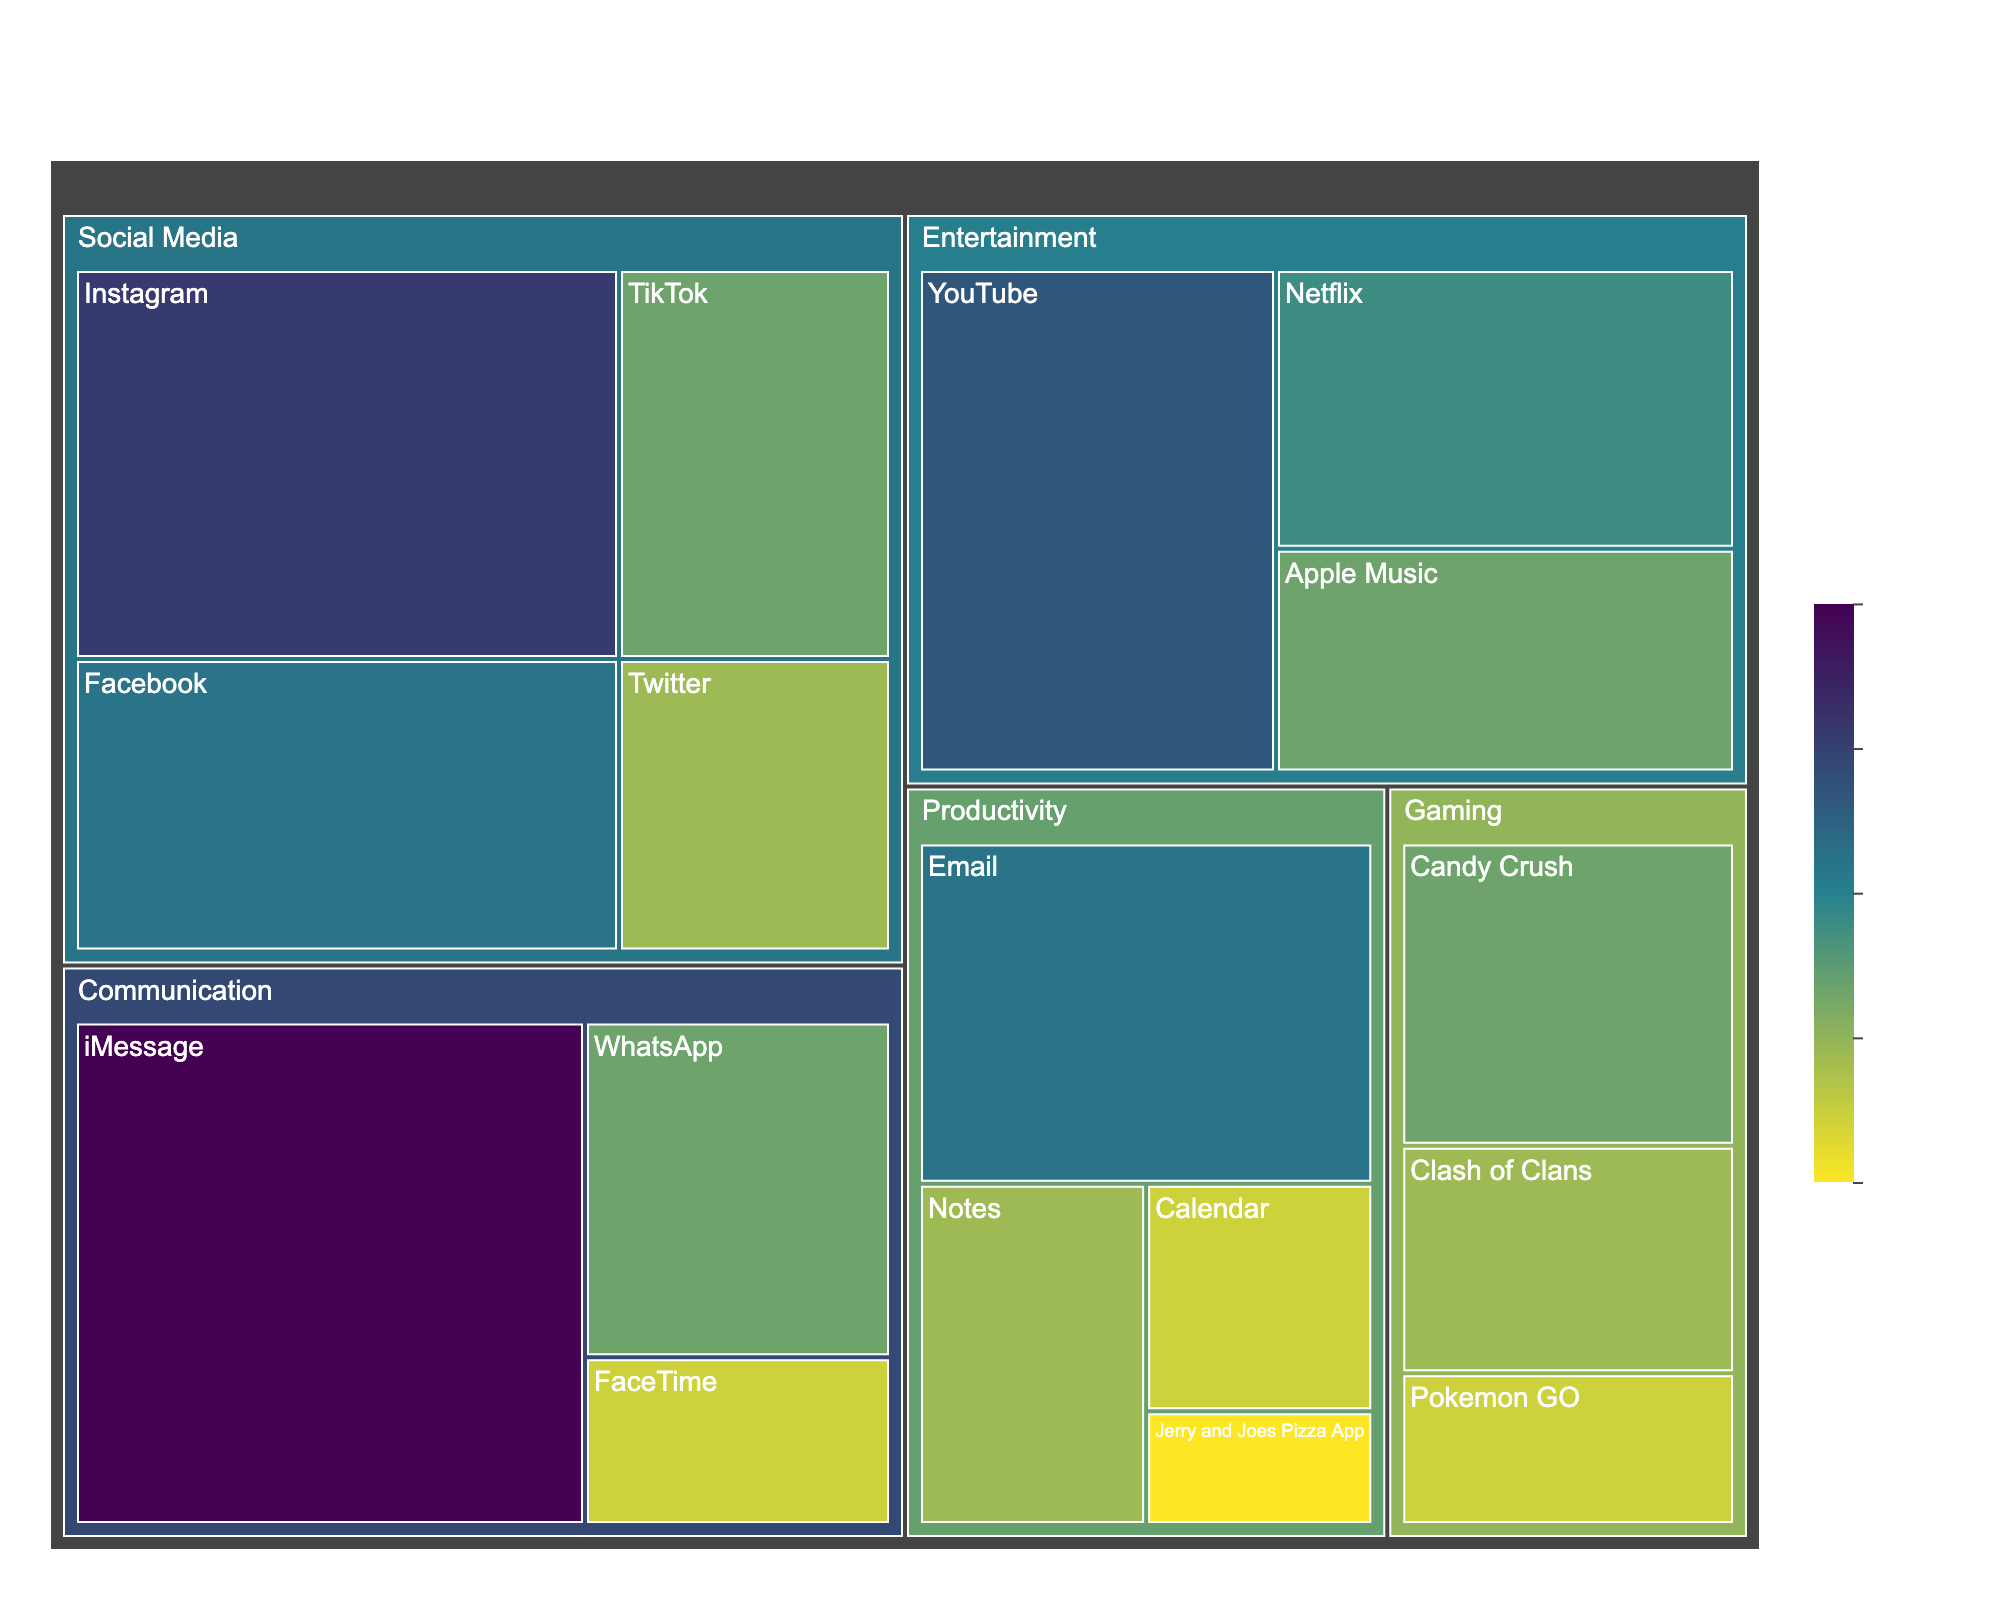What is the title of the treemap? The title of the treemap is usually located at the top of the figure. In this case, the title is "Smartphone Usage Statistics" with a subtitle "Time Spent on Various Activities".
Answer: Smartphone Usage Statistics Which activity category has the highest time spent? To find the category with the highest time spent, look for the largest section in the treemap. The largest section corresponds to "Communication" as it includes the highest time spent subactivity, iMessage.
Answer: Communication How much time is spent on Instagram compared to Facebook? Identify the time spent on Instagram and Facebook from the treemap. Instagram has 120 minutes, and Facebook has 90 minutes. Subtract to find the difference. 120 - 90 = 30 minutes.
Answer: 30 minutes Combine the time spent on all productivity activities. Sum the time spent on Email (90), Calendar (30), Notes (45), and Jerry and Joes Pizza App (15). The total is 90 + 30 + 45 + 15 = 180 minutes.
Answer: 180 minutes Which subcategory under Entertainment has the least time spent? Look under the Entertainment section and compare the subcategories: YouTube (105 minutes), Netflix (75 minutes), Apple Music (60 minutes). Apple Music has the least time spent.
Answer: Apple Music Which has more time spent: all Gaming activities combined or all Social Media activities combined? Sum the time for each category. Gaming: Candy Crush (60) + Clash of Clans (45) + Pokemon GO (30) = 135 minutes. Social Media: Instagram (120) + Facebook (90) + TikTok (60) + Twitter (45) = 315 minutes. Compare the sums.
Answer: Social Media What is the average time spent per subactivity in Communication? Sum the time spent on each subactivity in Communication: iMessage (150), WhatsApp (60), FaceTime (30) = 240 minutes. There are 3 subactivities, so average is 240/3 = 80 minutes.
Answer: 80 minutes How does the time spent on YouTube compare to time spent on Email? Look at the figures for each: YouTube is 105 minutes and Email is 90 minutes. Compare them; YouTube has more time spent.
Answer: YouTube What percentage of the total time is spent on iMessage? First, compute the total time by summing all subactivities. Total = 120+90+60+45+60+45+30+90+30+45+15+150+60+30+105+75+60 = 1200 minutes. Time spent on iMessage is 150 minutes. Percentage = (150/1200) * 100 = 12.5%.
Answer: 12.5% Which category has the least number of subactivities, and what are they? Identify the number of subactivities per category. Communication (3), Entertainment (3), Social Media (4), Gaming (3), Productivity (4). The least number of subactivities is found in several categories: Communication, Gaming, and Entertainment (each has 3 subactivities).
Answer: Communication, Gaming, Entertainment 